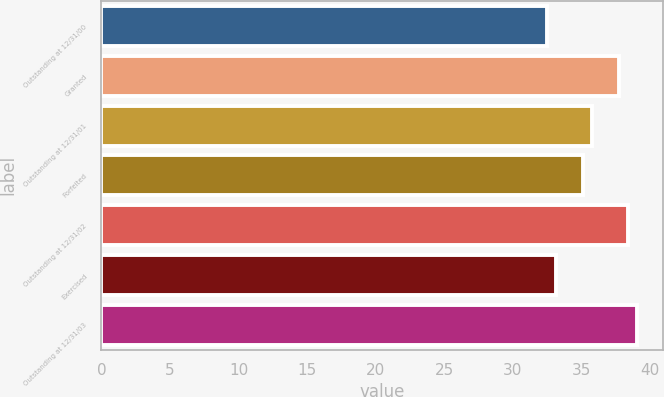Convert chart to OTSL. <chart><loc_0><loc_0><loc_500><loc_500><bar_chart><fcel>Outstanding at 12/31/00<fcel>Granted<fcel>Outstanding at 12/31/01<fcel>Forfeited<fcel>Outstanding at 12/31/02<fcel>Exercised<fcel>Outstanding at 12/31/03<nl><fcel>32.5<fcel>37.75<fcel>35.75<fcel>35.12<fcel>38.38<fcel>33.13<fcel>39.01<nl></chart> 